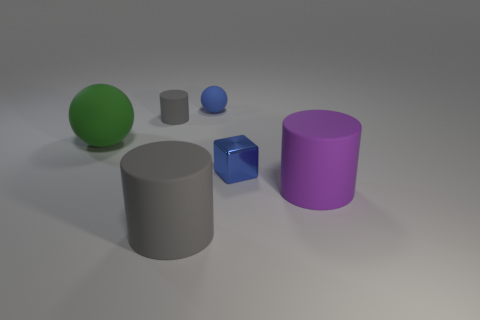Add 1 purple blocks. How many objects exist? 7 Subtract all cubes. How many objects are left? 5 Subtract 2 cylinders. How many cylinders are left? 1 Subtract all green spheres. Subtract all yellow cylinders. How many spheres are left? 1 Subtract all purple cylinders. How many purple balls are left? 0 Subtract all big green rubber balls. Subtract all green matte objects. How many objects are left? 4 Add 2 small spheres. How many small spheres are left? 3 Add 3 small balls. How many small balls exist? 4 Subtract all gray cylinders. How many cylinders are left? 1 Subtract all tiny matte cylinders. How many cylinders are left? 2 